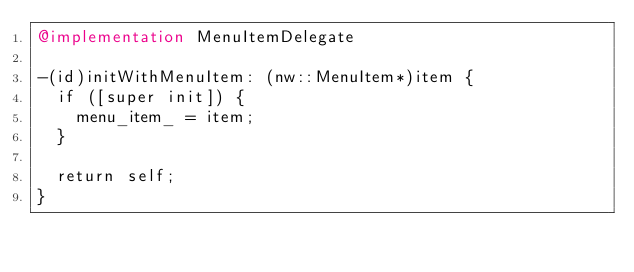<code> <loc_0><loc_0><loc_500><loc_500><_ObjectiveC_>@implementation MenuItemDelegate

-(id)initWithMenuItem: (nw::MenuItem*)item {
  if ([super init]) {
    menu_item_ = item;
  }

  return self;
}
</code> 